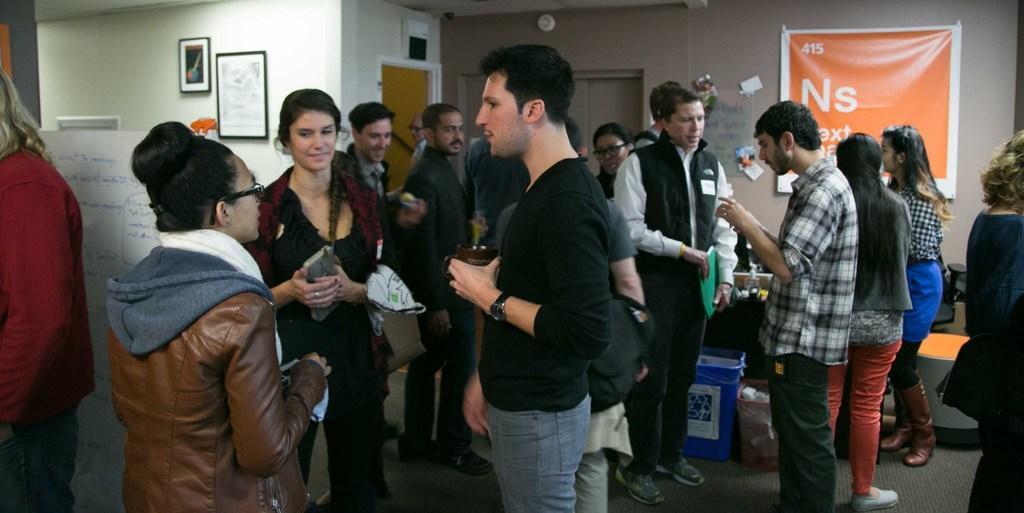Describe this image in one or two sentences. In this image, there are group of people wearing clothes and standing in front of the wall. There is a banner in the top right of the image. There is a basket at the bottom of the image. There is a photo frame in the top left of the image. There is a board on the left side of the image. 